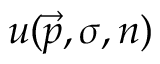<formula> <loc_0><loc_0><loc_500><loc_500>u ( { \vec { p } } , \sigma , n )</formula> 